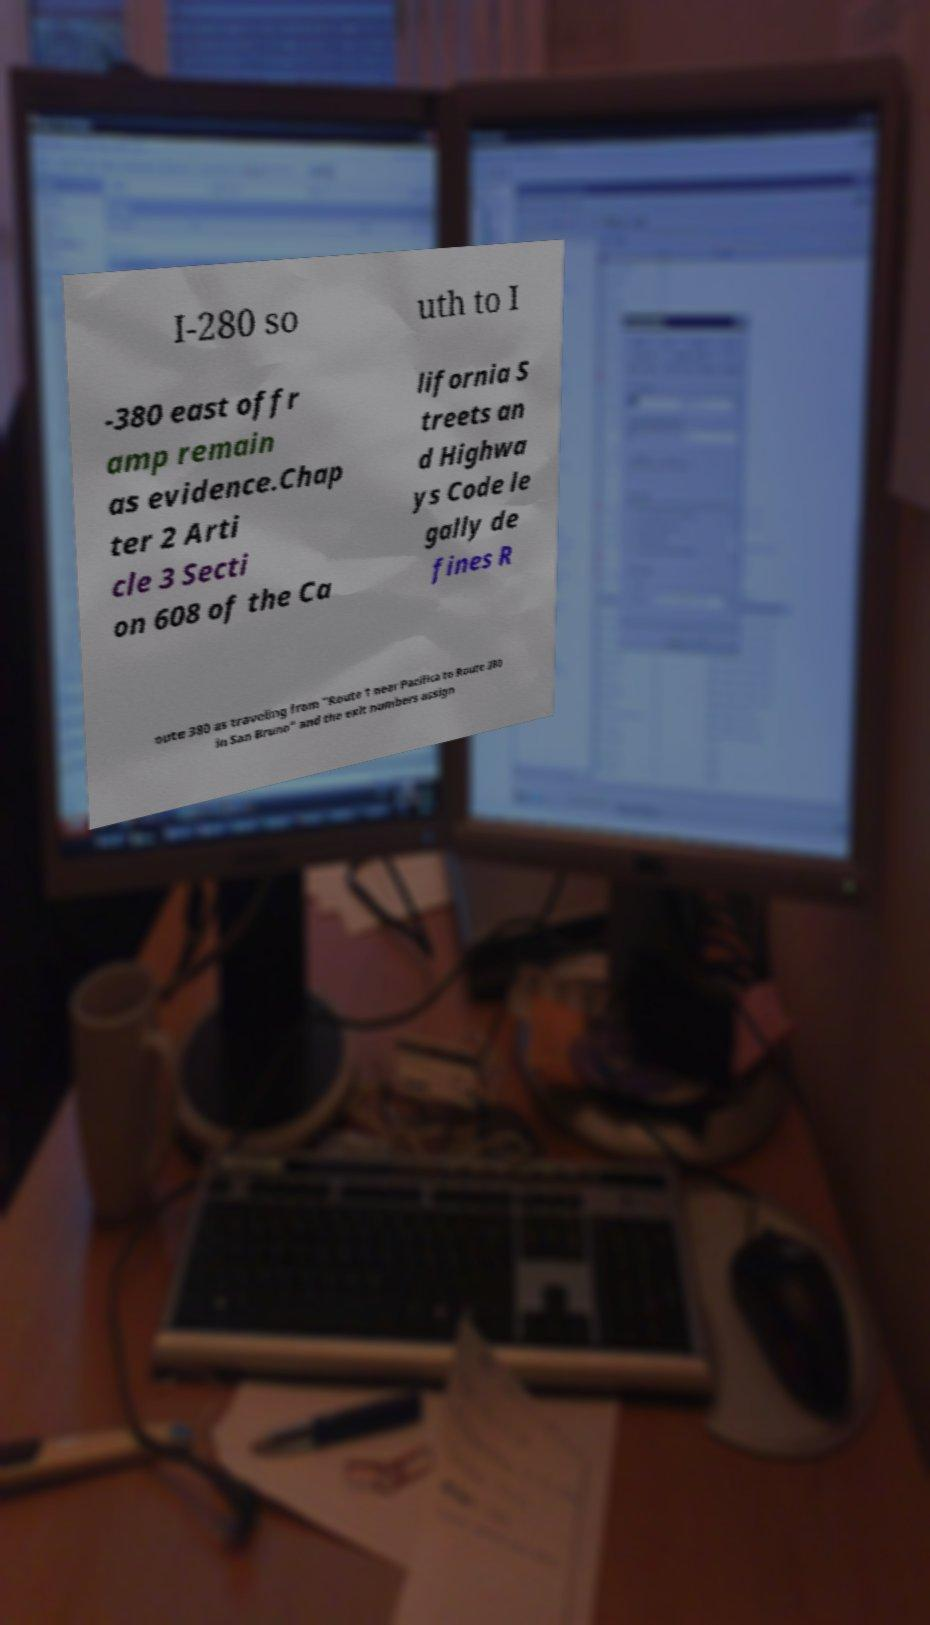Could you assist in decoding the text presented in this image and type it out clearly? I-280 so uth to I -380 east offr amp remain as evidence.Chap ter 2 Arti cle 3 Secti on 608 of the Ca lifornia S treets an d Highwa ys Code le gally de fines R oute 380 as traveling from "Route 1 near Pacifica to Route 280 in San Bruno" and the exit numbers assign 